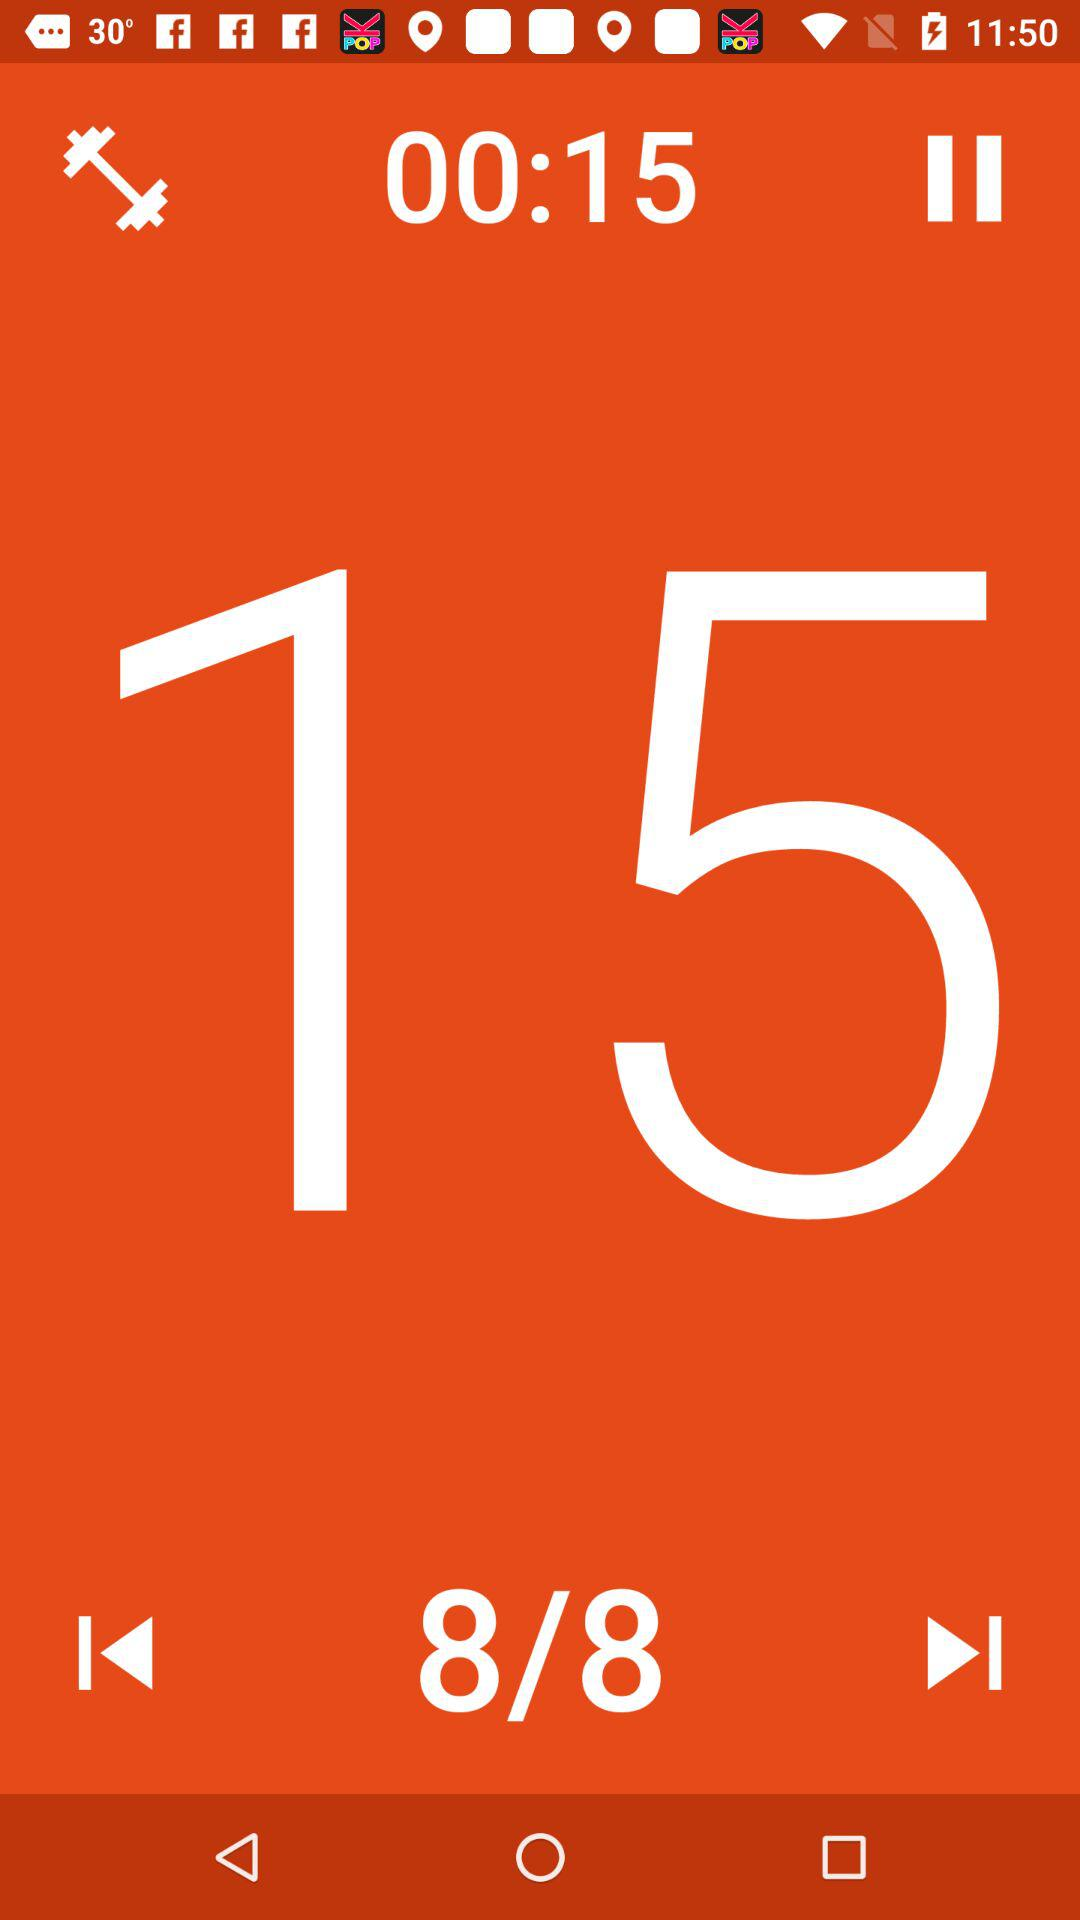What is the name of the application?
When the provided information is insufficient, respond with <no answer>. <no answer> 